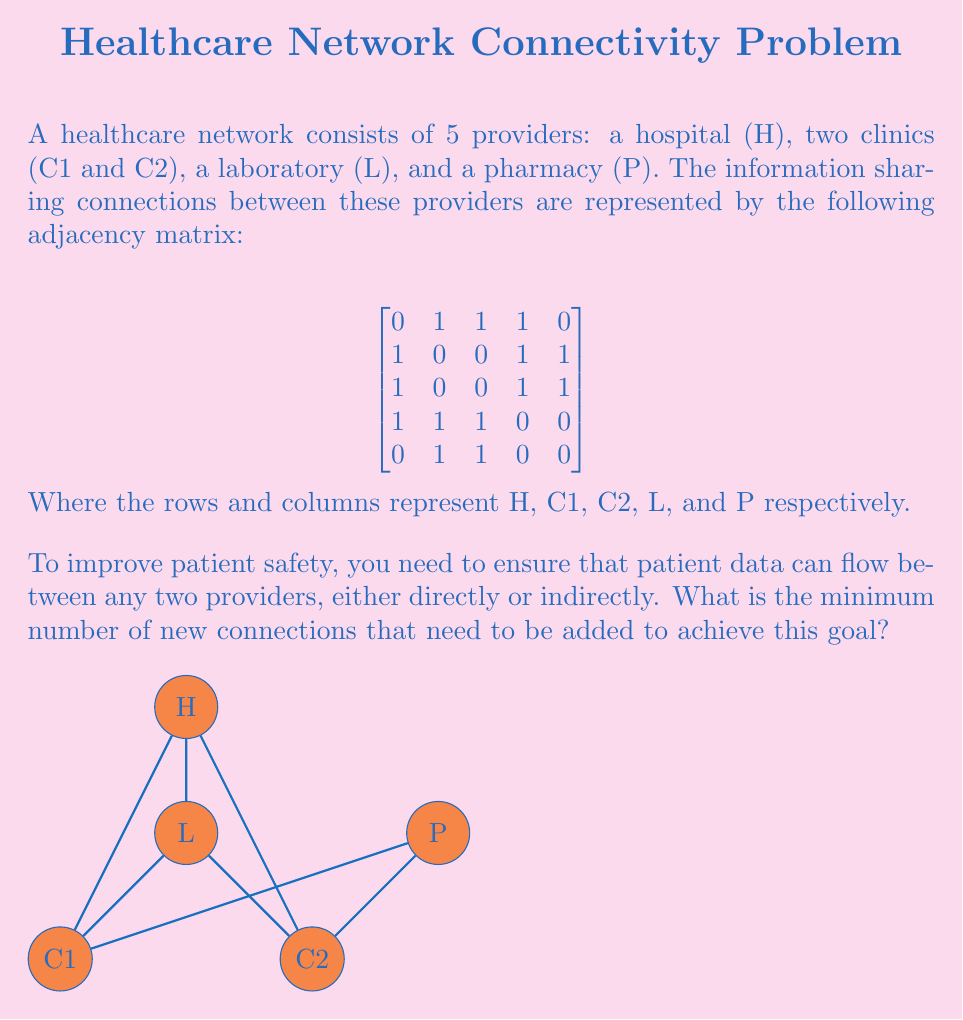Show me your answer to this math problem. To solve this problem, we need to analyze the connectivity of the graph and determine if it's already connected or how many edges are needed to make it connected. Let's approach this step-by-step:

1) First, let's identify the existing connections from the adjacency matrix:
   - H is connected to C1, C2, and L
   - C1 is connected to H, L, and P
   - C2 is connected to H, L, and P
   - L is connected to H, C1, and C2
   - P is connected to C1 and C2

2) Now, let's check if there's a path between every pair of nodes:
   - H can reach all other nodes (directly or through C1/C2)
   - C1 can reach all other nodes (directly or through H)
   - C2 can reach all other nodes (directly or through H)
   - L can reach all other nodes (directly or through H)
   - P can reach all other nodes (through C1 or C2)

3) Since there's a path between every pair of nodes, the graph is already connected.

4) The definition of a connected graph is that there exists a path between any two vertices. In this case, that condition is already satisfied.

5) Therefore, no new connections need to be added to achieve the goal of ensuring that patient data can flow between any two providers.
Answer: 0 